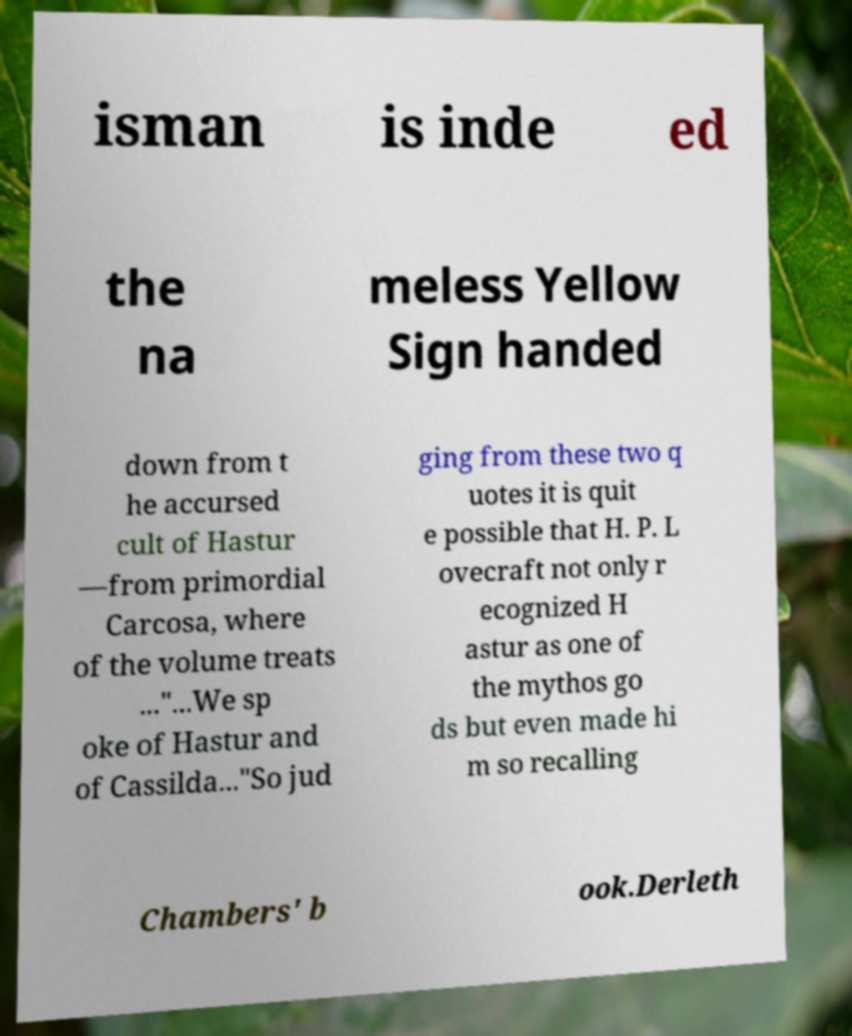What messages or text are displayed in this image? I need them in a readable, typed format. isman is inde ed the na meless Yellow Sign handed down from t he accursed cult of Hastur —from primordial Carcosa, where of the volume treats ..."...We sp oke of Hastur and of Cassilda..."So jud ging from these two q uotes it is quit e possible that H. P. L ovecraft not only r ecognized H astur as one of the mythos go ds but even made hi m so recalling Chambers' b ook.Derleth 